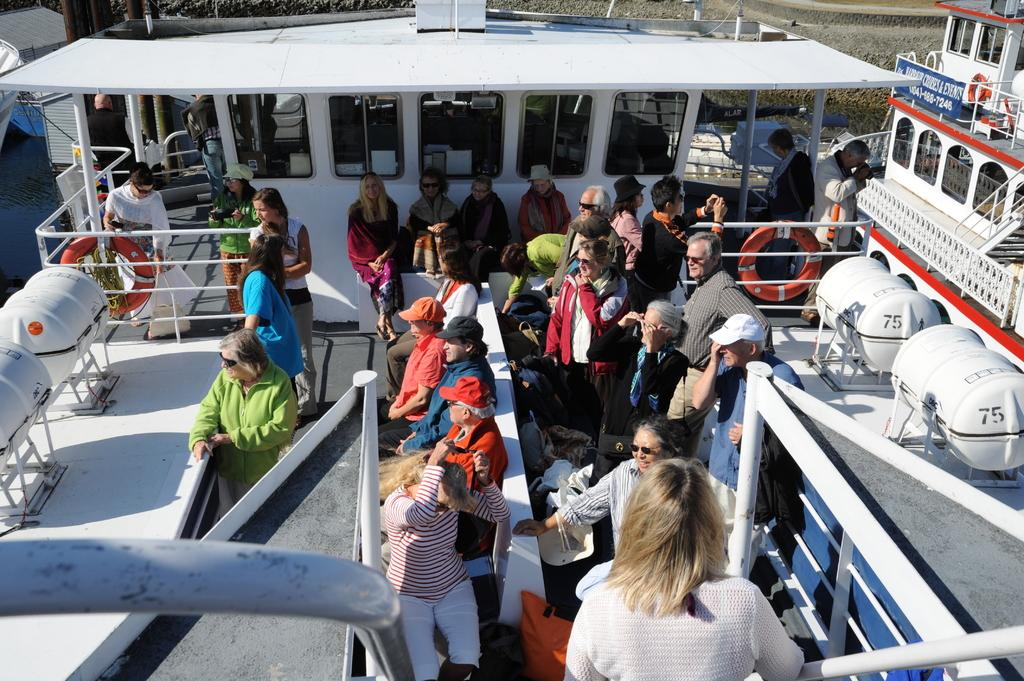What is the main subject of the picture? The main subject of the picture is a ship. Are there any people on the ship? Yes, there are people on the ship. What are some of the activities the people on the ship are doing? Some people on the ship are sitting, while others are standing and watching. What type of sugar is being used to sweeten the drinks on the ship? There is no information about drinks or sugar in the image, so it cannot be determined. 